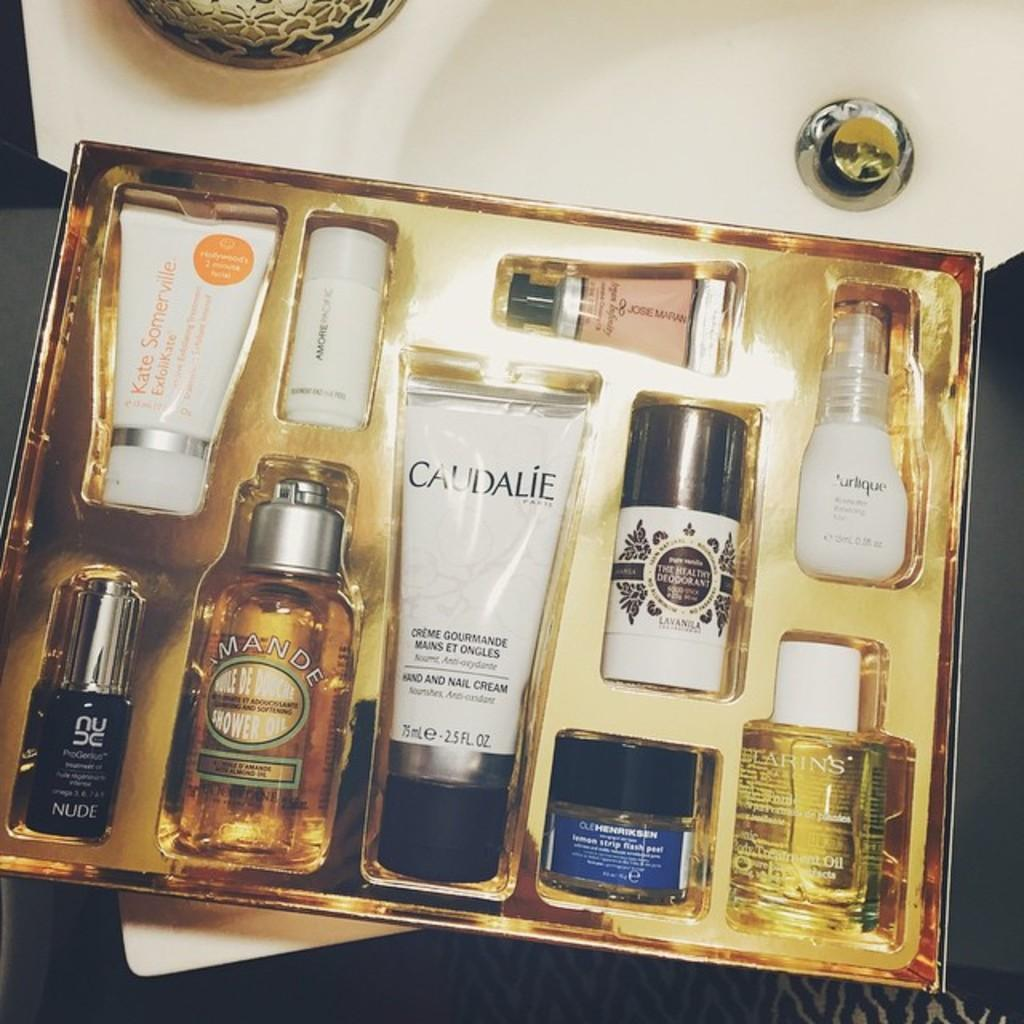<image>
Present a compact description of the photo's key features. A gift box with a bottle of Cuadalie in it. 